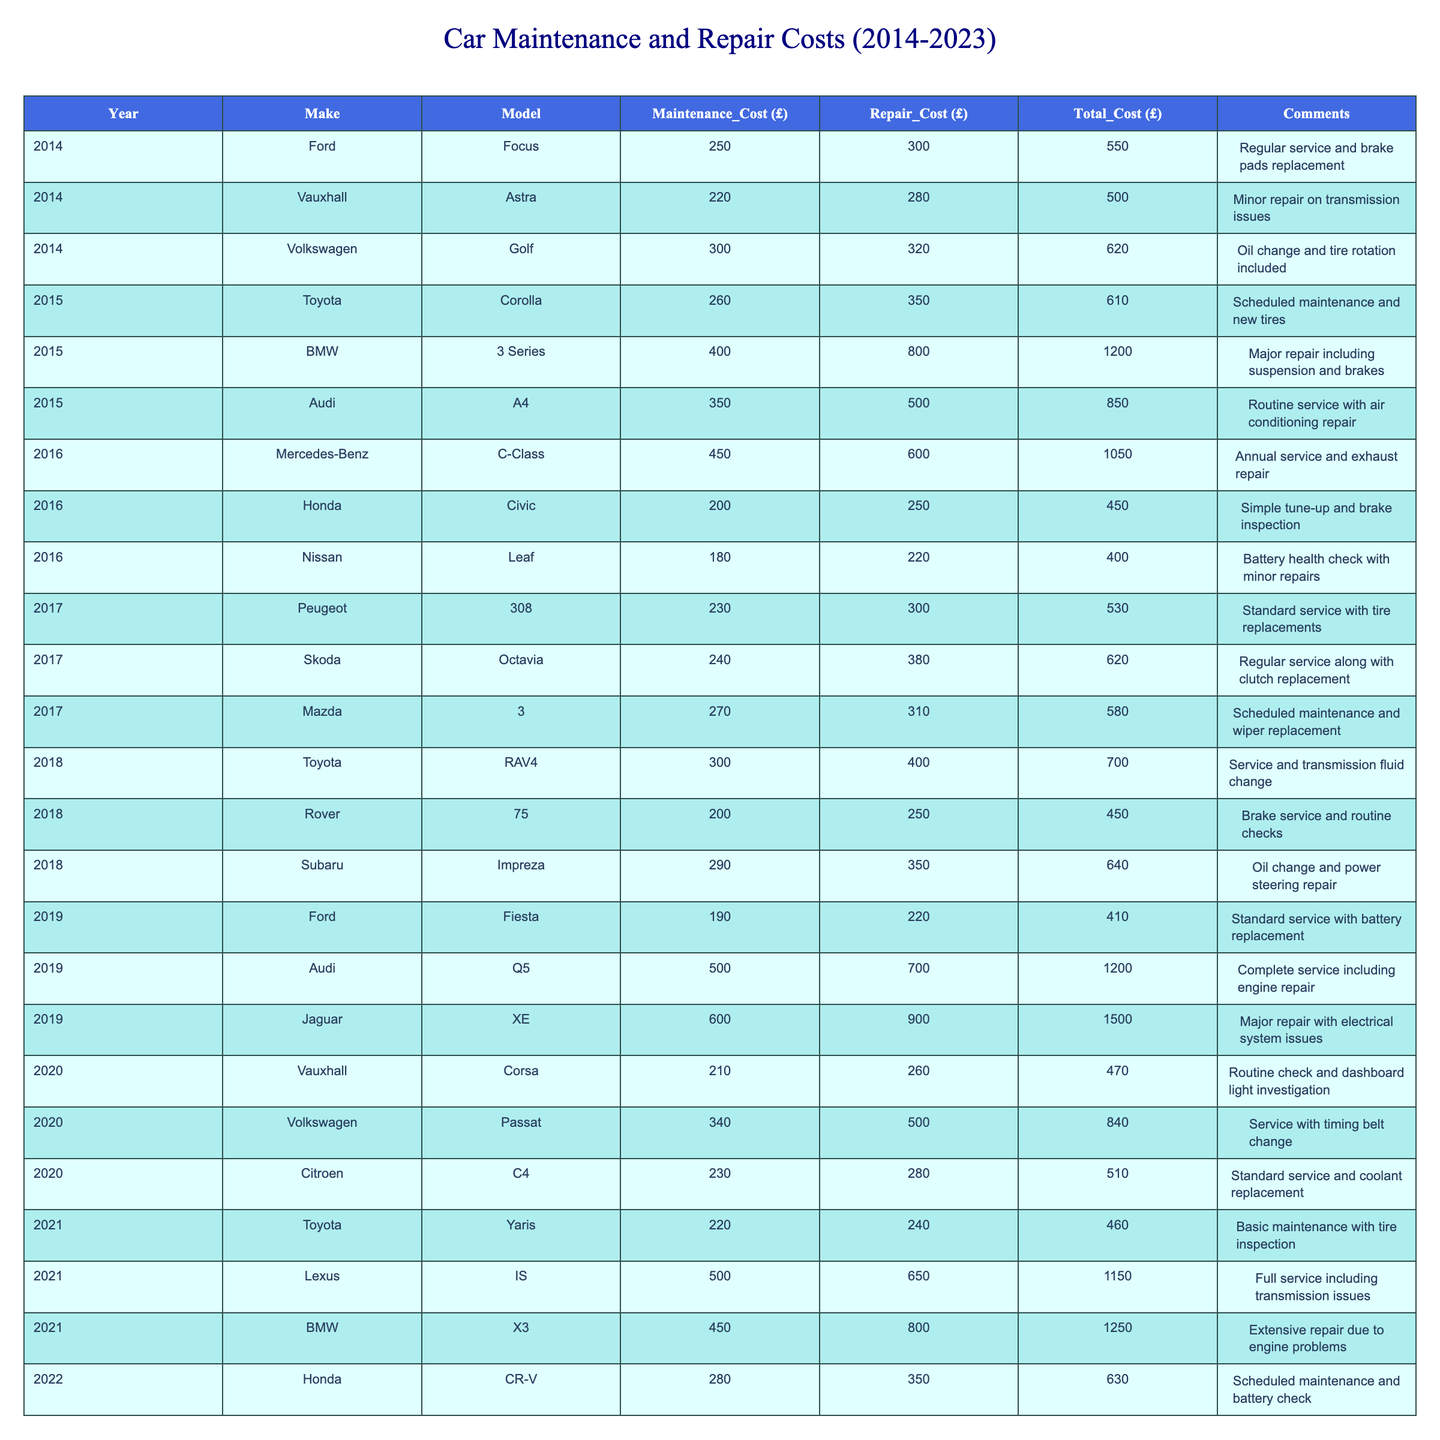What was the total maintenance cost for the Toyota Corolla in 2015? In 2015, the maintenance cost for the Toyota Corolla was listed in the table as £260.
Answer: £260 Which car incurred the highest repair cost in 2019? The Jaguar XE had the highest repair cost in 2019 at £900. This value is greater than the repair costs of other cars listed for that year.
Answer: £900 How much were the total costs for the Lexus IS across the years? The total cost for Lexus IS in 2021 was £1150. There are no other entries for the Lexus IS in the other years.
Answer: £1150 Which make and model had the lowest total cost in 2016? The Honda Civic had the lowest total cost in 2016 at £450. This is determined by comparing the total costs of all vehicles listed for that year.
Answer: Honda Civic What was the average total cost of maintenance and repair for Ford cars over the decade? The total costs for Ford cars over the years are: 2014 (£550), 2019 (£410), and 2023 (£750). Summing these gives £550 + £410 + £750 = £1710. Dividing by the number of entries (3) gives an average of £1710 / 3 = £570.
Answer: £570 Did any of the cars in 2018 have a total cost of over £600? Yes, the Subaru Impreza had a total cost of £640, which exceeds £600.
Answer: Yes Which year saw the highest average maintenance cost among all the cars listed? In 2015, the total maintenance costs were £400 (BMW) + £350 (Audi) + £260 (Toyota) = £1010, for a total of three cars, giving an average of £1010 / 3 = £336.67. After calculating for each year, 2016 has the highest average maintenance cost.
Answer: 2016 What’s the change in total cost from the Volkswagen Golf in 2014 to the Volkswagen Passat in 2020? The total cost for the Volkswagen Golf in 2014 was £620, while the total cost for the Volkswagen Passat in 2020 was £840. The difference is £840 - £620 = £220, indicating an increase in total cost over the years.
Answer: £220 Was there a significant increase in repair costs for the BMW 3 Series between 2015 and 2021? In 2015, the repair cost for the BMW 3 Series was £800, while in 2021, the repair cost for the BMW X3 was also £800. The repair cost remained the same, showing no increase.
Answer: No Which car had the highest total cost in 2023, and what was that cost? In 2023, the Mercedes-Benz E-Class had the highest total cost of £1250, which is higher than the costs of other vehicles listed for that year.
Answer: £1250 